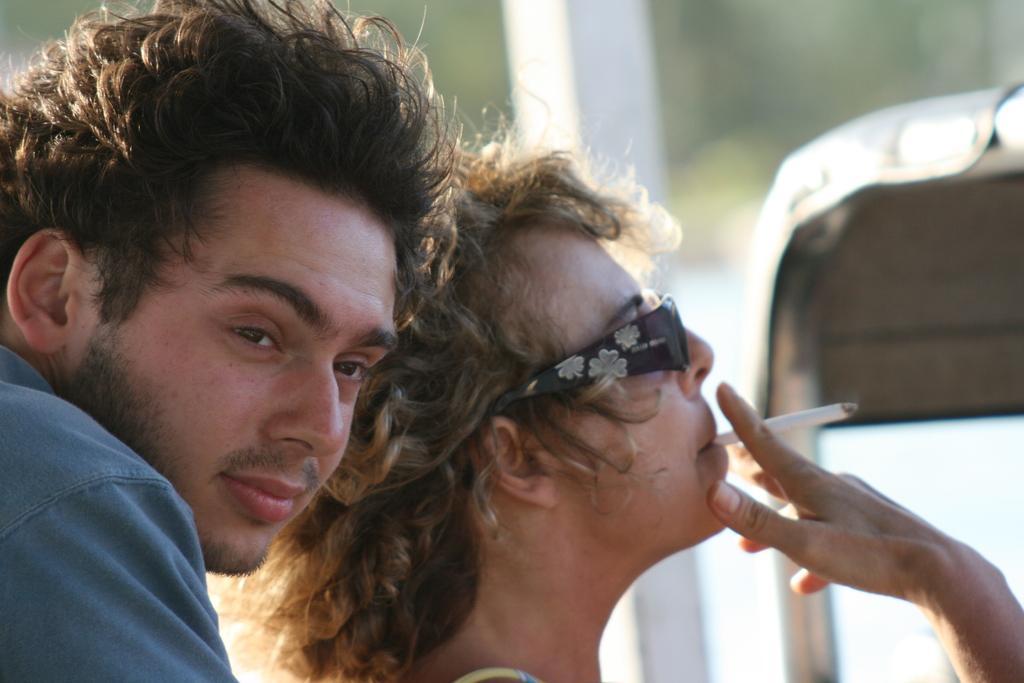Please provide a concise description of this image. In the picture I can see two persons among them one person is smoking cigar. 